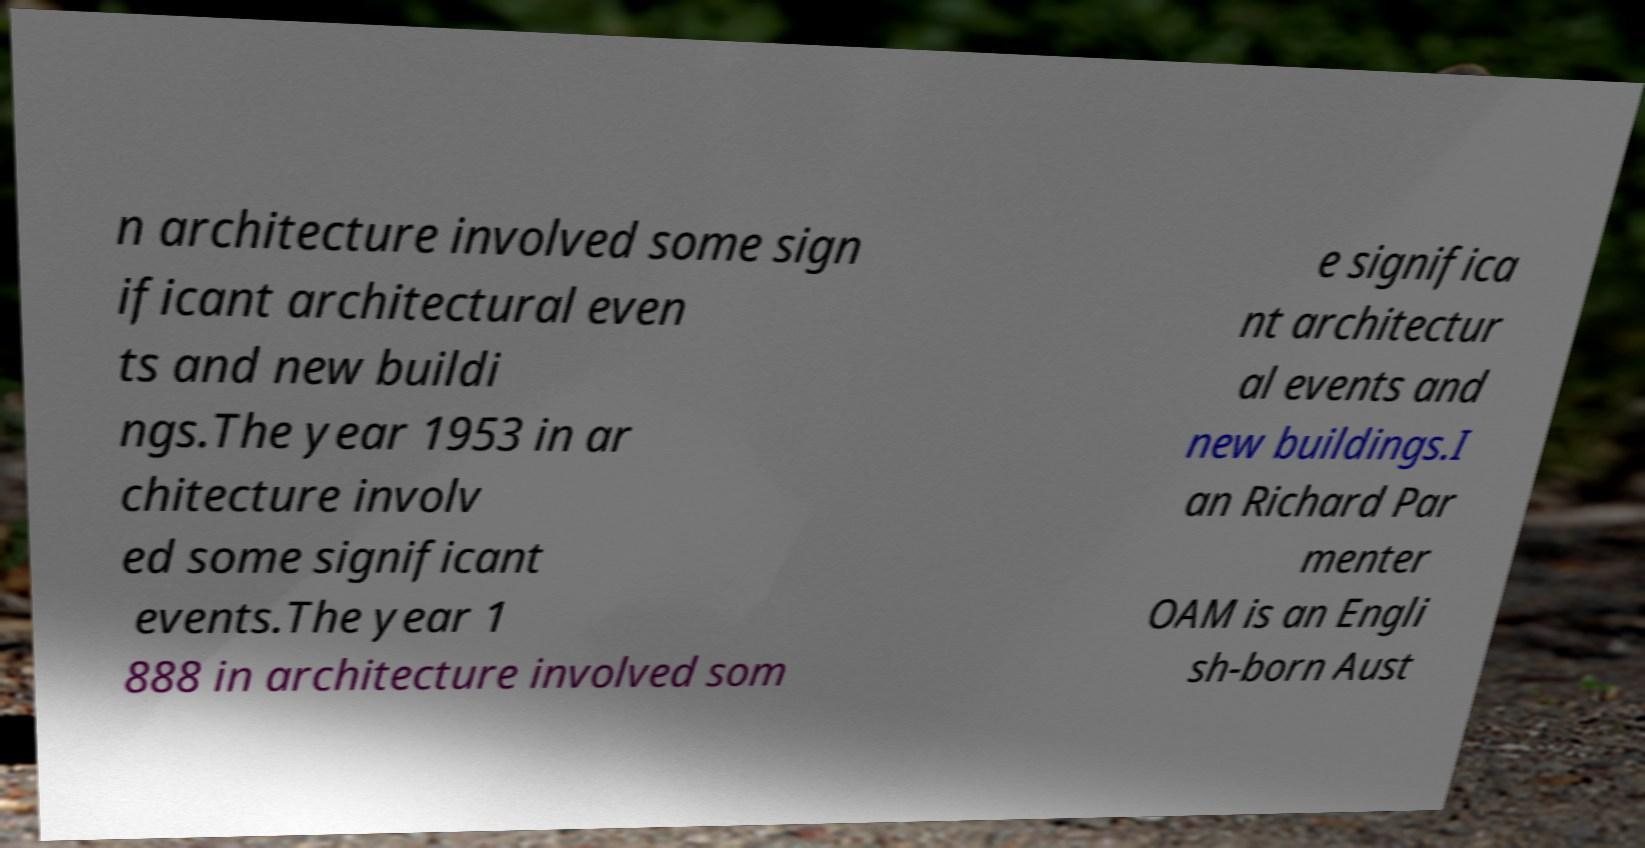Please read and relay the text visible in this image. What does it say? n architecture involved some sign ificant architectural even ts and new buildi ngs.The year 1953 in ar chitecture involv ed some significant events.The year 1 888 in architecture involved som e significa nt architectur al events and new buildings.I an Richard Par menter OAM is an Engli sh-born Aust 